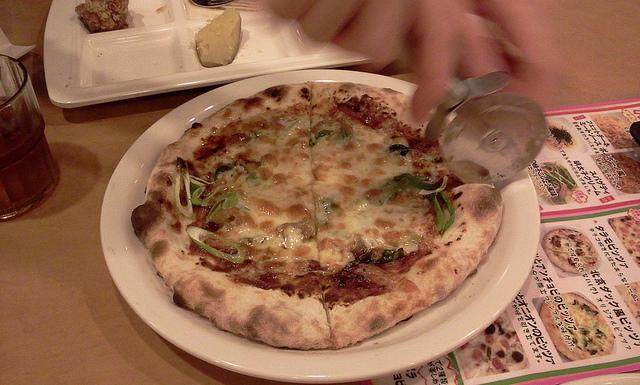In which style white pizza made of? Please explain your reasoning. italian. Pizza comes from italy. 